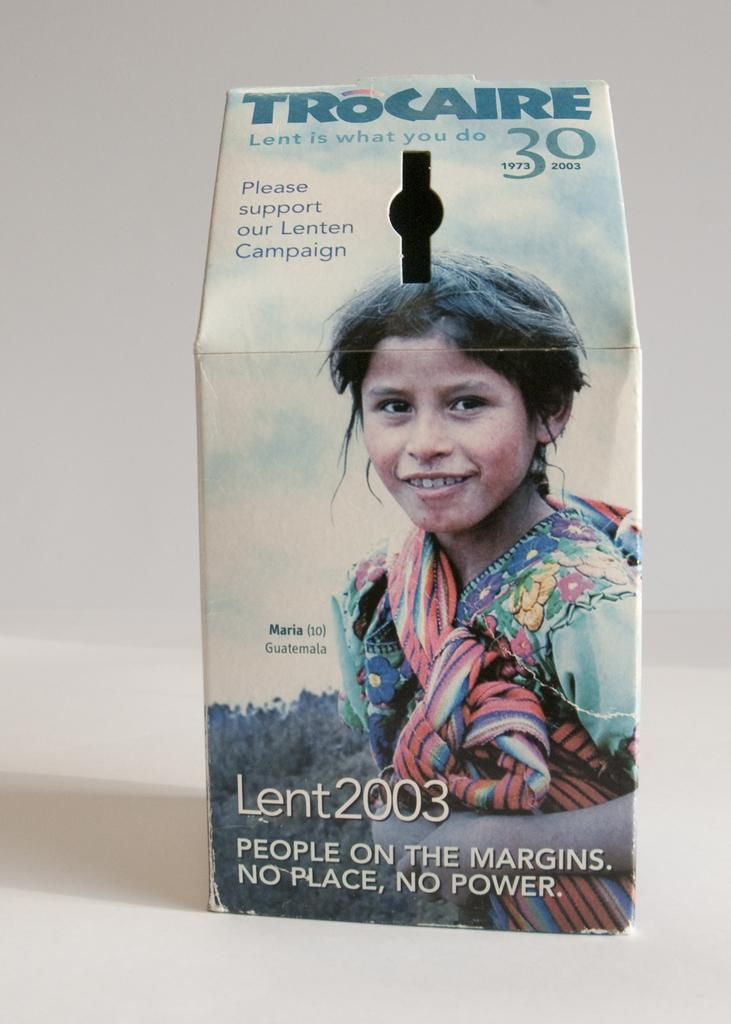What object is present in the image that could contain items? There is a box in the image that could contain items. Where is the box located in the image? The box is on a platform in the image. What is depicted on the box? There is a girl's picture on the box. Is there any text on the box? Yes, text is written on the box. How does the girl's picture on the box protect against an attack in the image? The girl's picture on the box does not protect against an attack, as it is a static image on a box and not a protective measure. 